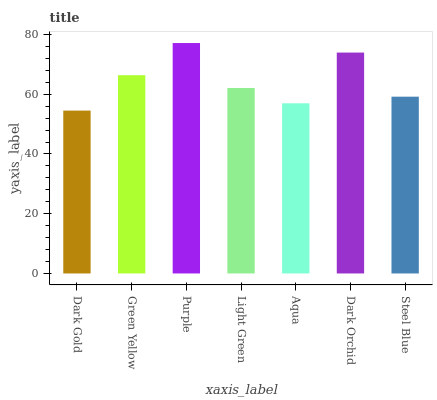Is Dark Gold the minimum?
Answer yes or no. Yes. Is Purple the maximum?
Answer yes or no. Yes. Is Green Yellow the minimum?
Answer yes or no. No. Is Green Yellow the maximum?
Answer yes or no. No. Is Green Yellow greater than Dark Gold?
Answer yes or no. Yes. Is Dark Gold less than Green Yellow?
Answer yes or no. Yes. Is Dark Gold greater than Green Yellow?
Answer yes or no. No. Is Green Yellow less than Dark Gold?
Answer yes or no. No. Is Light Green the high median?
Answer yes or no. Yes. Is Light Green the low median?
Answer yes or no. Yes. Is Dark Orchid the high median?
Answer yes or no. No. Is Aqua the low median?
Answer yes or no. No. 